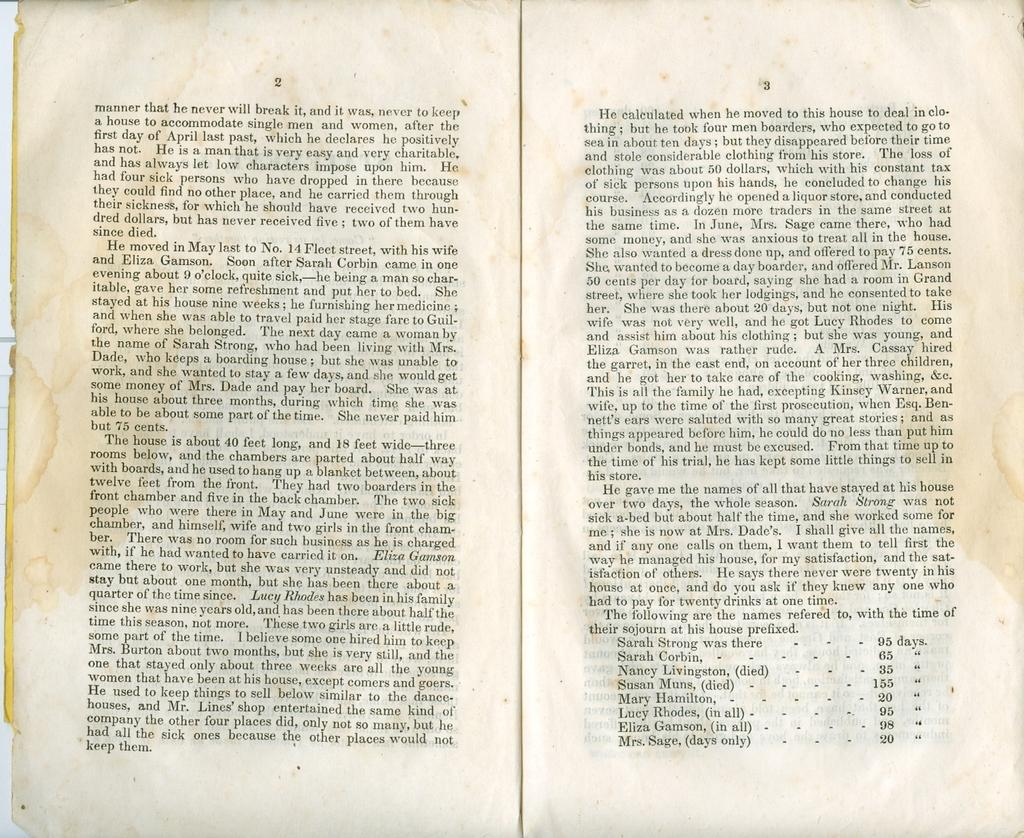<image>
Give a short and clear explanation of the subsequent image. A book is open to pages 2 and 3, which includes the information that Sarah Strong was there for 95 days. 